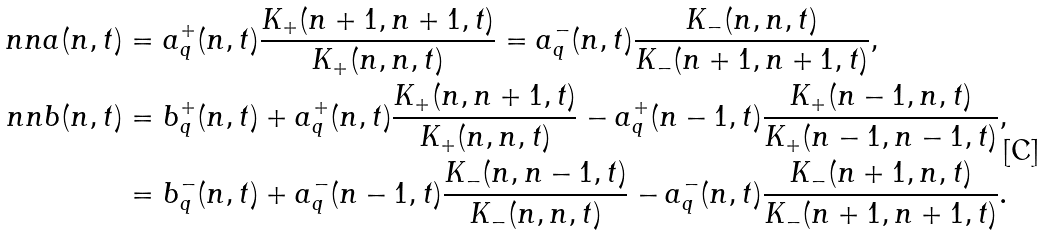Convert formula to latex. <formula><loc_0><loc_0><loc_500><loc_500>\ n n a ( n , t ) & = a _ { q } ^ { + } ( n , t ) \frac { K _ { + } ( n + 1 , n + 1 , t ) } { K _ { + } ( n , n , t ) } = a _ { q } ^ { - } ( n , t ) \frac { K _ { - } ( n , n , t ) } { K _ { - } ( n + 1 , n + 1 , t ) } , \\ \ n n b ( n , t ) & = b _ { q } ^ { + } ( n , t ) + a _ { q } ^ { + } ( n , t ) \frac { K _ { + } ( n , n + 1 , t ) } { K _ { + } ( n , n , t ) } - a _ { q } ^ { + } ( n - 1 , t ) \frac { K _ { + } ( n - 1 , n , t ) } { K _ { + } ( n - 1 , n - 1 , t ) } , \\ & = b _ { q } ^ { - } ( n , t ) + a _ { q } ^ { - } ( n - 1 , t ) \frac { K _ { - } ( n , n - 1 , t ) } { K _ { - } ( n , n , t ) } - a _ { q } ^ { - } ( n , t ) \frac { K _ { - } ( n + 1 , n , t ) } { K _ { - } ( n + 1 , n + 1 , t ) } .</formula> 